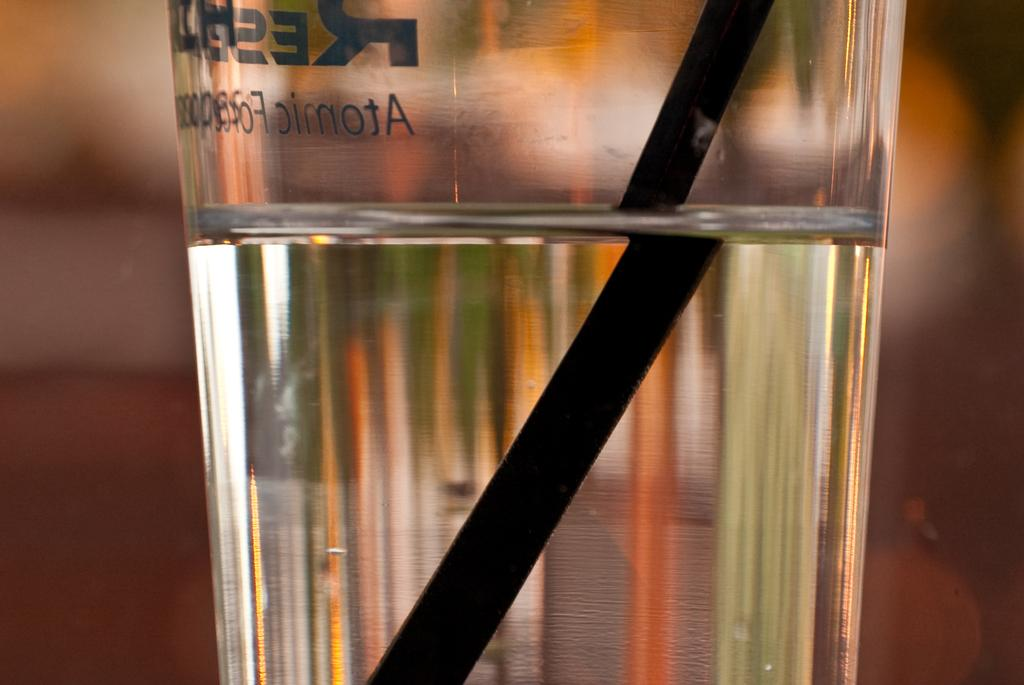<image>
Describe the image concisely. a glass with the word atomic on it 